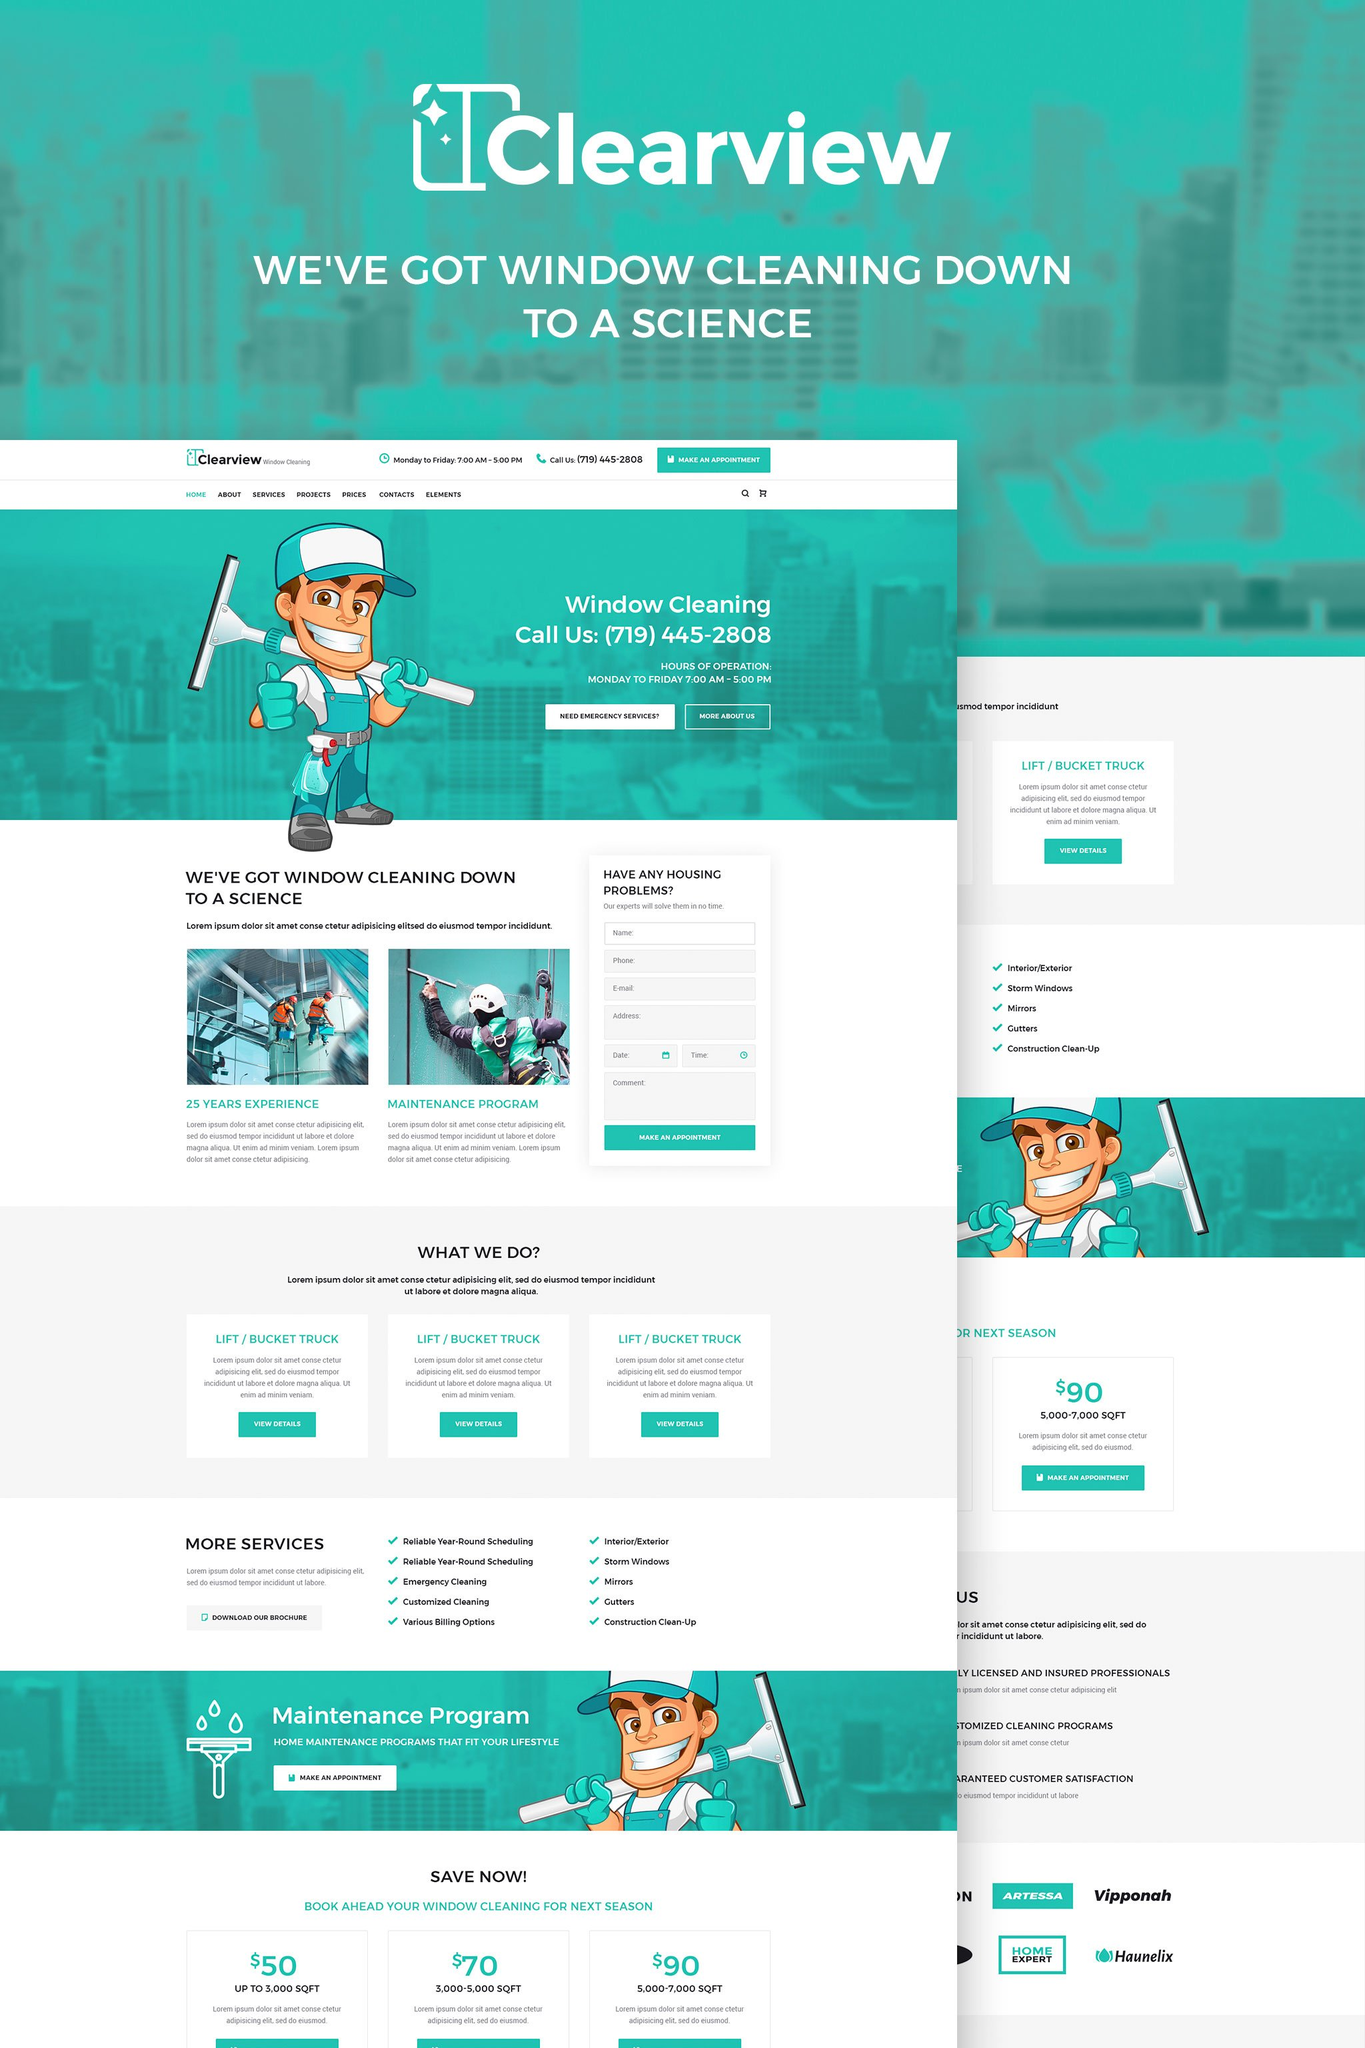How does Clearview's webpage address urgent cleaning needs? Clearview's webpage addresses urgent cleaning needs by prominently featuring an 'Emergency Services' section. This option suggests that they are prepared to offer prompt responses and services for urgent cleaning situations, which can be critical for potential clients needing immediate assistance. 